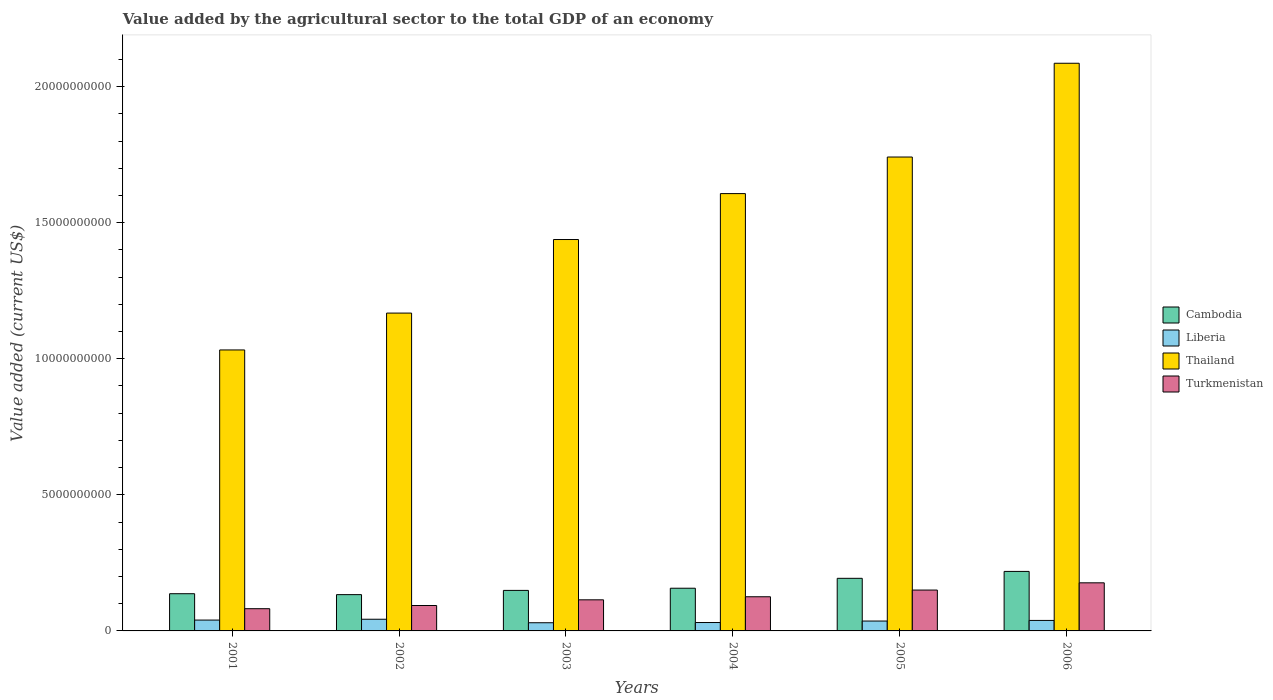How many different coloured bars are there?
Provide a succinct answer. 4. How many groups of bars are there?
Provide a succinct answer. 6. Are the number of bars per tick equal to the number of legend labels?
Your answer should be compact. Yes. How many bars are there on the 6th tick from the right?
Keep it short and to the point. 4. What is the value added by the agricultural sector to the total GDP in Cambodia in 2003?
Give a very brief answer. 1.49e+09. Across all years, what is the maximum value added by the agricultural sector to the total GDP in Liberia?
Your response must be concise. 4.29e+08. Across all years, what is the minimum value added by the agricultural sector to the total GDP in Thailand?
Your response must be concise. 1.03e+1. In which year was the value added by the agricultural sector to the total GDP in Turkmenistan maximum?
Your answer should be very brief. 2006. What is the total value added by the agricultural sector to the total GDP in Liberia in the graph?
Offer a terse response. 2.19e+09. What is the difference between the value added by the agricultural sector to the total GDP in Liberia in 2001 and that in 2003?
Offer a terse response. 9.82e+07. What is the difference between the value added by the agricultural sector to the total GDP in Thailand in 2001 and the value added by the agricultural sector to the total GDP in Turkmenistan in 2004?
Give a very brief answer. 9.07e+09. What is the average value added by the agricultural sector to the total GDP in Thailand per year?
Keep it short and to the point. 1.51e+1. In the year 2003, what is the difference between the value added by the agricultural sector to the total GDP in Liberia and value added by the agricultural sector to the total GDP in Thailand?
Your answer should be very brief. -1.41e+1. In how many years, is the value added by the agricultural sector to the total GDP in Thailand greater than 19000000000 US$?
Your answer should be compact. 1. What is the ratio of the value added by the agricultural sector to the total GDP in Thailand in 2001 to that in 2006?
Ensure brevity in your answer.  0.49. Is the difference between the value added by the agricultural sector to the total GDP in Liberia in 2003 and 2005 greater than the difference between the value added by the agricultural sector to the total GDP in Thailand in 2003 and 2005?
Give a very brief answer. Yes. What is the difference between the highest and the second highest value added by the agricultural sector to the total GDP in Liberia?
Make the answer very short. 3.05e+07. What is the difference between the highest and the lowest value added by the agricultural sector to the total GDP in Cambodia?
Ensure brevity in your answer.  8.53e+08. Is it the case that in every year, the sum of the value added by the agricultural sector to the total GDP in Liberia and value added by the agricultural sector to the total GDP in Cambodia is greater than the sum of value added by the agricultural sector to the total GDP in Turkmenistan and value added by the agricultural sector to the total GDP in Thailand?
Keep it short and to the point. No. What does the 2nd bar from the left in 2002 represents?
Offer a terse response. Liberia. What does the 3rd bar from the right in 2003 represents?
Make the answer very short. Liberia. Are the values on the major ticks of Y-axis written in scientific E-notation?
Offer a terse response. No. Does the graph contain any zero values?
Your answer should be compact. No. Does the graph contain grids?
Offer a terse response. No. How many legend labels are there?
Your answer should be very brief. 4. What is the title of the graph?
Your answer should be compact. Value added by the agricultural sector to the total GDP of an economy. What is the label or title of the Y-axis?
Offer a terse response. Value added (current US$). What is the Value added (current US$) in Cambodia in 2001?
Offer a terse response. 1.37e+09. What is the Value added (current US$) of Liberia in 2001?
Keep it short and to the point. 3.99e+08. What is the Value added (current US$) of Thailand in 2001?
Your answer should be very brief. 1.03e+1. What is the Value added (current US$) of Turkmenistan in 2001?
Your answer should be very brief. 8.16e+08. What is the Value added (current US$) of Cambodia in 2002?
Your response must be concise. 1.33e+09. What is the Value added (current US$) in Liberia in 2002?
Your answer should be very brief. 4.29e+08. What is the Value added (current US$) in Thailand in 2002?
Your answer should be compact. 1.17e+1. What is the Value added (current US$) of Turkmenistan in 2002?
Make the answer very short. 9.34e+08. What is the Value added (current US$) of Cambodia in 2003?
Provide a succinct answer. 1.49e+09. What is the Value added (current US$) in Liberia in 2003?
Offer a terse response. 3.01e+08. What is the Value added (current US$) in Thailand in 2003?
Keep it short and to the point. 1.44e+1. What is the Value added (current US$) of Turkmenistan in 2003?
Keep it short and to the point. 1.14e+09. What is the Value added (current US$) in Cambodia in 2004?
Your response must be concise. 1.57e+09. What is the Value added (current US$) in Liberia in 2004?
Offer a terse response. 3.09e+08. What is the Value added (current US$) in Thailand in 2004?
Your answer should be compact. 1.61e+1. What is the Value added (current US$) in Turkmenistan in 2004?
Your response must be concise. 1.26e+09. What is the Value added (current US$) in Cambodia in 2005?
Your response must be concise. 1.93e+09. What is the Value added (current US$) in Liberia in 2005?
Offer a terse response. 3.63e+08. What is the Value added (current US$) in Thailand in 2005?
Offer a terse response. 1.74e+1. What is the Value added (current US$) of Turkmenistan in 2005?
Provide a succinct answer. 1.50e+09. What is the Value added (current US$) in Cambodia in 2006?
Offer a very short reply. 2.19e+09. What is the Value added (current US$) in Liberia in 2006?
Make the answer very short. 3.85e+08. What is the Value added (current US$) in Thailand in 2006?
Keep it short and to the point. 2.09e+1. What is the Value added (current US$) of Turkmenistan in 2006?
Make the answer very short. 1.77e+09. Across all years, what is the maximum Value added (current US$) of Cambodia?
Give a very brief answer. 2.19e+09. Across all years, what is the maximum Value added (current US$) of Liberia?
Offer a very short reply. 4.29e+08. Across all years, what is the maximum Value added (current US$) of Thailand?
Provide a short and direct response. 2.09e+1. Across all years, what is the maximum Value added (current US$) in Turkmenistan?
Ensure brevity in your answer.  1.77e+09. Across all years, what is the minimum Value added (current US$) in Cambodia?
Your answer should be compact. 1.33e+09. Across all years, what is the minimum Value added (current US$) in Liberia?
Provide a succinct answer. 3.01e+08. Across all years, what is the minimum Value added (current US$) of Thailand?
Keep it short and to the point. 1.03e+1. Across all years, what is the minimum Value added (current US$) in Turkmenistan?
Your answer should be compact. 8.16e+08. What is the total Value added (current US$) of Cambodia in the graph?
Give a very brief answer. 9.88e+09. What is the total Value added (current US$) of Liberia in the graph?
Your answer should be compact. 2.19e+09. What is the total Value added (current US$) of Thailand in the graph?
Provide a short and direct response. 9.07e+1. What is the total Value added (current US$) of Turkmenistan in the graph?
Offer a very short reply. 7.42e+09. What is the difference between the Value added (current US$) of Cambodia in 2001 and that in 2002?
Provide a short and direct response. 3.37e+07. What is the difference between the Value added (current US$) in Liberia in 2001 and that in 2002?
Provide a short and direct response. -3.05e+07. What is the difference between the Value added (current US$) in Thailand in 2001 and that in 2002?
Your answer should be compact. -1.35e+09. What is the difference between the Value added (current US$) of Turkmenistan in 2001 and that in 2002?
Give a very brief answer. -1.18e+08. What is the difference between the Value added (current US$) in Cambodia in 2001 and that in 2003?
Your answer should be very brief. -1.22e+08. What is the difference between the Value added (current US$) of Liberia in 2001 and that in 2003?
Offer a very short reply. 9.82e+07. What is the difference between the Value added (current US$) of Thailand in 2001 and that in 2003?
Keep it short and to the point. -4.06e+09. What is the difference between the Value added (current US$) of Turkmenistan in 2001 and that in 2003?
Give a very brief answer. -3.26e+08. What is the difference between the Value added (current US$) in Cambodia in 2001 and that in 2004?
Keep it short and to the point. -2.01e+08. What is the difference between the Value added (current US$) of Liberia in 2001 and that in 2004?
Make the answer very short. 9.00e+07. What is the difference between the Value added (current US$) in Thailand in 2001 and that in 2004?
Provide a short and direct response. -5.74e+09. What is the difference between the Value added (current US$) in Turkmenistan in 2001 and that in 2004?
Offer a very short reply. -4.39e+08. What is the difference between the Value added (current US$) of Cambodia in 2001 and that in 2005?
Offer a very short reply. -5.65e+08. What is the difference between the Value added (current US$) in Liberia in 2001 and that in 2005?
Provide a short and direct response. 3.56e+07. What is the difference between the Value added (current US$) in Thailand in 2001 and that in 2005?
Offer a very short reply. -7.09e+09. What is the difference between the Value added (current US$) in Turkmenistan in 2001 and that in 2005?
Make the answer very short. -6.85e+08. What is the difference between the Value added (current US$) in Cambodia in 2001 and that in 2006?
Offer a terse response. -8.19e+08. What is the difference between the Value added (current US$) in Liberia in 2001 and that in 2006?
Provide a short and direct response. 1.33e+07. What is the difference between the Value added (current US$) of Thailand in 2001 and that in 2006?
Your answer should be compact. -1.05e+1. What is the difference between the Value added (current US$) in Turkmenistan in 2001 and that in 2006?
Provide a succinct answer. -9.51e+08. What is the difference between the Value added (current US$) of Cambodia in 2002 and that in 2003?
Offer a very short reply. -1.56e+08. What is the difference between the Value added (current US$) in Liberia in 2002 and that in 2003?
Keep it short and to the point. 1.29e+08. What is the difference between the Value added (current US$) of Thailand in 2002 and that in 2003?
Provide a succinct answer. -2.70e+09. What is the difference between the Value added (current US$) of Turkmenistan in 2002 and that in 2003?
Make the answer very short. -2.09e+08. What is the difference between the Value added (current US$) of Cambodia in 2002 and that in 2004?
Keep it short and to the point. -2.35e+08. What is the difference between the Value added (current US$) of Liberia in 2002 and that in 2004?
Provide a short and direct response. 1.20e+08. What is the difference between the Value added (current US$) of Thailand in 2002 and that in 2004?
Offer a very short reply. -4.39e+09. What is the difference between the Value added (current US$) of Turkmenistan in 2002 and that in 2004?
Offer a terse response. -3.21e+08. What is the difference between the Value added (current US$) of Cambodia in 2002 and that in 2005?
Keep it short and to the point. -5.99e+08. What is the difference between the Value added (current US$) in Liberia in 2002 and that in 2005?
Offer a very short reply. 6.60e+07. What is the difference between the Value added (current US$) in Thailand in 2002 and that in 2005?
Offer a very short reply. -5.73e+09. What is the difference between the Value added (current US$) of Turkmenistan in 2002 and that in 2005?
Keep it short and to the point. -5.68e+08. What is the difference between the Value added (current US$) in Cambodia in 2002 and that in 2006?
Your answer should be compact. -8.53e+08. What is the difference between the Value added (current US$) of Liberia in 2002 and that in 2006?
Offer a very short reply. 4.37e+07. What is the difference between the Value added (current US$) of Thailand in 2002 and that in 2006?
Ensure brevity in your answer.  -9.18e+09. What is the difference between the Value added (current US$) in Turkmenistan in 2002 and that in 2006?
Offer a very short reply. -8.33e+08. What is the difference between the Value added (current US$) in Cambodia in 2003 and that in 2004?
Provide a succinct answer. -7.95e+07. What is the difference between the Value added (current US$) of Liberia in 2003 and that in 2004?
Your answer should be compact. -8.26e+06. What is the difference between the Value added (current US$) in Thailand in 2003 and that in 2004?
Make the answer very short. -1.69e+09. What is the difference between the Value added (current US$) of Turkmenistan in 2003 and that in 2004?
Provide a succinct answer. -1.12e+08. What is the difference between the Value added (current US$) of Cambodia in 2003 and that in 2005?
Provide a short and direct response. -4.43e+08. What is the difference between the Value added (current US$) of Liberia in 2003 and that in 2005?
Your response must be concise. -6.27e+07. What is the difference between the Value added (current US$) in Thailand in 2003 and that in 2005?
Offer a terse response. -3.03e+09. What is the difference between the Value added (current US$) in Turkmenistan in 2003 and that in 2005?
Your answer should be very brief. -3.59e+08. What is the difference between the Value added (current US$) in Cambodia in 2003 and that in 2006?
Keep it short and to the point. -6.97e+08. What is the difference between the Value added (current US$) of Liberia in 2003 and that in 2006?
Keep it short and to the point. -8.50e+07. What is the difference between the Value added (current US$) of Thailand in 2003 and that in 2006?
Offer a terse response. -6.48e+09. What is the difference between the Value added (current US$) of Turkmenistan in 2003 and that in 2006?
Provide a succinct answer. -6.25e+08. What is the difference between the Value added (current US$) in Cambodia in 2004 and that in 2005?
Offer a very short reply. -3.64e+08. What is the difference between the Value added (current US$) in Liberia in 2004 and that in 2005?
Your answer should be very brief. -5.44e+07. What is the difference between the Value added (current US$) of Thailand in 2004 and that in 2005?
Offer a very short reply. -1.34e+09. What is the difference between the Value added (current US$) in Turkmenistan in 2004 and that in 2005?
Provide a succinct answer. -2.47e+08. What is the difference between the Value added (current US$) in Cambodia in 2004 and that in 2006?
Keep it short and to the point. -6.18e+08. What is the difference between the Value added (current US$) in Liberia in 2004 and that in 2006?
Keep it short and to the point. -7.67e+07. What is the difference between the Value added (current US$) of Thailand in 2004 and that in 2006?
Offer a very short reply. -4.79e+09. What is the difference between the Value added (current US$) in Turkmenistan in 2004 and that in 2006?
Offer a very short reply. -5.12e+08. What is the difference between the Value added (current US$) of Cambodia in 2005 and that in 2006?
Provide a short and direct response. -2.54e+08. What is the difference between the Value added (current US$) in Liberia in 2005 and that in 2006?
Offer a very short reply. -2.23e+07. What is the difference between the Value added (current US$) in Thailand in 2005 and that in 2006?
Offer a very short reply. -3.45e+09. What is the difference between the Value added (current US$) in Turkmenistan in 2005 and that in 2006?
Make the answer very short. -2.66e+08. What is the difference between the Value added (current US$) of Cambodia in 2001 and the Value added (current US$) of Liberia in 2002?
Your answer should be compact. 9.38e+08. What is the difference between the Value added (current US$) of Cambodia in 2001 and the Value added (current US$) of Thailand in 2002?
Your response must be concise. -1.03e+1. What is the difference between the Value added (current US$) of Cambodia in 2001 and the Value added (current US$) of Turkmenistan in 2002?
Offer a terse response. 4.33e+08. What is the difference between the Value added (current US$) of Liberia in 2001 and the Value added (current US$) of Thailand in 2002?
Give a very brief answer. -1.13e+1. What is the difference between the Value added (current US$) in Liberia in 2001 and the Value added (current US$) in Turkmenistan in 2002?
Offer a very short reply. -5.35e+08. What is the difference between the Value added (current US$) in Thailand in 2001 and the Value added (current US$) in Turkmenistan in 2002?
Give a very brief answer. 9.39e+09. What is the difference between the Value added (current US$) in Cambodia in 2001 and the Value added (current US$) in Liberia in 2003?
Offer a very short reply. 1.07e+09. What is the difference between the Value added (current US$) in Cambodia in 2001 and the Value added (current US$) in Thailand in 2003?
Offer a terse response. -1.30e+1. What is the difference between the Value added (current US$) in Cambodia in 2001 and the Value added (current US$) in Turkmenistan in 2003?
Your answer should be very brief. 2.24e+08. What is the difference between the Value added (current US$) in Liberia in 2001 and the Value added (current US$) in Thailand in 2003?
Make the answer very short. -1.40e+1. What is the difference between the Value added (current US$) of Liberia in 2001 and the Value added (current US$) of Turkmenistan in 2003?
Offer a very short reply. -7.44e+08. What is the difference between the Value added (current US$) in Thailand in 2001 and the Value added (current US$) in Turkmenistan in 2003?
Offer a very short reply. 9.18e+09. What is the difference between the Value added (current US$) in Cambodia in 2001 and the Value added (current US$) in Liberia in 2004?
Provide a succinct answer. 1.06e+09. What is the difference between the Value added (current US$) in Cambodia in 2001 and the Value added (current US$) in Thailand in 2004?
Offer a very short reply. -1.47e+1. What is the difference between the Value added (current US$) in Cambodia in 2001 and the Value added (current US$) in Turkmenistan in 2004?
Offer a terse response. 1.12e+08. What is the difference between the Value added (current US$) in Liberia in 2001 and the Value added (current US$) in Thailand in 2004?
Keep it short and to the point. -1.57e+1. What is the difference between the Value added (current US$) of Liberia in 2001 and the Value added (current US$) of Turkmenistan in 2004?
Your answer should be very brief. -8.56e+08. What is the difference between the Value added (current US$) of Thailand in 2001 and the Value added (current US$) of Turkmenistan in 2004?
Your response must be concise. 9.07e+09. What is the difference between the Value added (current US$) of Cambodia in 2001 and the Value added (current US$) of Liberia in 2005?
Your response must be concise. 1.00e+09. What is the difference between the Value added (current US$) of Cambodia in 2001 and the Value added (current US$) of Thailand in 2005?
Provide a short and direct response. -1.60e+1. What is the difference between the Value added (current US$) in Cambodia in 2001 and the Value added (current US$) in Turkmenistan in 2005?
Provide a short and direct response. -1.34e+08. What is the difference between the Value added (current US$) of Liberia in 2001 and the Value added (current US$) of Thailand in 2005?
Your response must be concise. -1.70e+1. What is the difference between the Value added (current US$) in Liberia in 2001 and the Value added (current US$) in Turkmenistan in 2005?
Your answer should be very brief. -1.10e+09. What is the difference between the Value added (current US$) in Thailand in 2001 and the Value added (current US$) in Turkmenistan in 2005?
Give a very brief answer. 8.82e+09. What is the difference between the Value added (current US$) of Cambodia in 2001 and the Value added (current US$) of Liberia in 2006?
Keep it short and to the point. 9.82e+08. What is the difference between the Value added (current US$) of Cambodia in 2001 and the Value added (current US$) of Thailand in 2006?
Offer a terse response. -1.95e+1. What is the difference between the Value added (current US$) of Cambodia in 2001 and the Value added (current US$) of Turkmenistan in 2006?
Offer a very short reply. -4.00e+08. What is the difference between the Value added (current US$) in Liberia in 2001 and the Value added (current US$) in Thailand in 2006?
Ensure brevity in your answer.  -2.05e+1. What is the difference between the Value added (current US$) in Liberia in 2001 and the Value added (current US$) in Turkmenistan in 2006?
Your answer should be very brief. -1.37e+09. What is the difference between the Value added (current US$) of Thailand in 2001 and the Value added (current US$) of Turkmenistan in 2006?
Make the answer very short. 8.56e+09. What is the difference between the Value added (current US$) in Cambodia in 2002 and the Value added (current US$) in Liberia in 2003?
Keep it short and to the point. 1.03e+09. What is the difference between the Value added (current US$) of Cambodia in 2002 and the Value added (current US$) of Thailand in 2003?
Your answer should be very brief. -1.30e+1. What is the difference between the Value added (current US$) in Cambodia in 2002 and the Value added (current US$) in Turkmenistan in 2003?
Your answer should be compact. 1.91e+08. What is the difference between the Value added (current US$) of Liberia in 2002 and the Value added (current US$) of Thailand in 2003?
Offer a terse response. -1.40e+1. What is the difference between the Value added (current US$) in Liberia in 2002 and the Value added (current US$) in Turkmenistan in 2003?
Keep it short and to the point. -7.14e+08. What is the difference between the Value added (current US$) in Thailand in 2002 and the Value added (current US$) in Turkmenistan in 2003?
Your answer should be compact. 1.05e+1. What is the difference between the Value added (current US$) in Cambodia in 2002 and the Value added (current US$) in Liberia in 2004?
Ensure brevity in your answer.  1.02e+09. What is the difference between the Value added (current US$) in Cambodia in 2002 and the Value added (current US$) in Thailand in 2004?
Offer a very short reply. -1.47e+1. What is the difference between the Value added (current US$) in Cambodia in 2002 and the Value added (current US$) in Turkmenistan in 2004?
Offer a terse response. 7.84e+07. What is the difference between the Value added (current US$) in Liberia in 2002 and the Value added (current US$) in Thailand in 2004?
Your answer should be very brief. -1.56e+1. What is the difference between the Value added (current US$) of Liberia in 2002 and the Value added (current US$) of Turkmenistan in 2004?
Keep it short and to the point. -8.26e+08. What is the difference between the Value added (current US$) in Thailand in 2002 and the Value added (current US$) in Turkmenistan in 2004?
Your response must be concise. 1.04e+1. What is the difference between the Value added (current US$) in Cambodia in 2002 and the Value added (current US$) in Liberia in 2005?
Provide a succinct answer. 9.70e+08. What is the difference between the Value added (current US$) of Cambodia in 2002 and the Value added (current US$) of Thailand in 2005?
Offer a very short reply. -1.61e+1. What is the difference between the Value added (current US$) of Cambodia in 2002 and the Value added (current US$) of Turkmenistan in 2005?
Keep it short and to the point. -1.68e+08. What is the difference between the Value added (current US$) in Liberia in 2002 and the Value added (current US$) in Thailand in 2005?
Ensure brevity in your answer.  -1.70e+1. What is the difference between the Value added (current US$) in Liberia in 2002 and the Value added (current US$) in Turkmenistan in 2005?
Make the answer very short. -1.07e+09. What is the difference between the Value added (current US$) of Thailand in 2002 and the Value added (current US$) of Turkmenistan in 2005?
Your answer should be very brief. 1.02e+1. What is the difference between the Value added (current US$) in Cambodia in 2002 and the Value added (current US$) in Liberia in 2006?
Keep it short and to the point. 9.48e+08. What is the difference between the Value added (current US$) in Cambodia in 2002 and the Value added (current US$) in Thailand in 2006?
Your answer should be very brief. -1.95e+1. What is the difference between the Value added (current US$) in Cambodia in 2002 and the Value added (current US$) in Turkmenistan in 2006?
Keep it short and to the point. -4.34e+08. What is the difference between the Value added (current US$) in Liberia in 2002 and the Value added (current US$) in Thailand in 2006?
Provide a short and direct response. -2.04e+1. What is the difference between the Value added (current US$) of Liberia in 2002 and the Value added (current US$) of Turkmenistan in 2006?
Provide a succinct answer. -1.34e+09. What is the difference between the Value added (current US$) of Thailand in 2002 and the Value added (current US$) of Turkmenistan in 2006?
Offer a terse response. 9.91e+09. What is the difference between the Value added (current US$) of Cambodia in 2003 and the Value added (current US$) of Liberia in 2004?
Ensure brevity in your answer.  1.18e+09. What is the difference between the Value added (current US$) of Cambodia in 2003 and the Value added (current US$) of Thailand in 2004?
Make the answer very short. -1.46e+1. What is the difference between the Value added (current US$) of Cambodia in 2003 and the Value added (current US$) of Turkmenistan in 2004?
Make the answer very short. 2.34e+08. What is the difference between the Value added (current US$) of Liberia in 2003 and the Value added (current US$) of Thailand in 2004?
Keep it short and to the point. -1.58e+1. What is the difference between the Value added (current US$) in Liberia in 2003 and the Value added (current US$) in Turkmenistan in 2004?
Offer a terse response. -9.55e+08. What is the difference between the Value added (current US$) of Thailand in 2003 and the Value added (current US$) of Turkmenistan in 2004?
Keep it short and to the point. 1.31e+1. What is the difference between the Value added (current US$) in Cambodia in 2003 and the Value added (current US$) in Liberia in 2005?
Give a very brief answer. 1.13e+09. What is the difference between the Value added (current US$) in Cambodia in 2003 and the Value added (current US$) in Thailand in 2005?
Keep it short and to the point. -1.59e+1. What is the difference between the Value added (current US$) of Cambodia in 2003 and the Value added (current US$) of Turkmenistan in 2005?
Offer a very short reply. -1.25e+07. What is the difference between the Value added (current US$) in Liberia in 2003 and the Value added (current US$) in Thailand in 2005?
Ensure brevity in your answer.  -1.71e+1. What is the difference between the Value added (current US$) of Liberia in 2003 and the Value added (current US$) of Turkmenistan in 2005?
Provide a short and direct response. -1.20e+09. What is the difference between the Value added (current US$) in Thailand in 2003 and the Value added (current US$) in Turkmenistan in 2005?
Provide a succinct answer. 1.29e+1. What is the difference between the Value added (current US$) in Cambodia in 2003 and the Value added (current US$) in Liberia in 2006?
Give a very brief answer. 1.10e+09. What is the difference between the Value added (current US$) of Cambodia in 2003 and the Value added (current US$) of Thailand in 2006?
Your response must be concise. -1.94e+1. What is the difference between the Value added (current US$) in Cambodia in 2003 and the Value added (current US$) in Turkmenistan in 2006?
Ensure brevity in your answer.  -2.78e+08. What is the difference between the Value added (current US$) in Liberia in 2003 and the Value added (current US$) in Thailand in 2006?
Your answer should be very brief. -2.06e+1. What is the difference between the Value added (current US$) of Liberia in 2003 and the Value added (current US$) of Turkmenistan in 2006?
Offer a very short reply. -1.47e+09. What is the difference between the Value added (current US$) in Thailand in 2003 and the Value added (current US$) in Turkmenistan in 2006?
Your answer should be compact. 1.26e+1. What is the difference between the Value added (current US$) in Cambodia in 2004 and the Value added (current US$) in Liberia in 2005?
Ensure brevity in your answer.  1.21e+09. What is the difference between the Value added (current US$) in Cambodia in 2004 and the Value added (current US$) in Thailand in 2005?
Make the answer very short. -1.58e+1. What is the difference between the Value added (current US$) of Cambodia in 2004 and the Value added (current US$) of Turkmenistan in 2005?
Make the answer very short. 6.70e+07. What is the difference between the Value added (current US$) of Liberia in 2004 and the Value added (current US$) of Thailand in 2005?
Your answer should be very brief. -1.71e+1. What is the difference between the Value added (current US$) of Liberia in 2004 and the Value added (current US$) of Turkmenistan in 2005?
Offer a very short reply. -1.19e+09. What is the difference between the Value added (current US$) of Thailand in 2004 and the Value added (current US$) of Turkmenistan in 2005?
Keep it short and to the point. 1.46e+1. What is the difference between the Value added (current US$) in Cambodia in 2004 and the Value added (current US$) in Liberia in 2006?
Your answer should be compact. 1.18e+09. What is the difference between the Value added (current US$) of Cambodia in 2004 and the Value added (current US$) of Thailand in 2006?
Your answer should be compact. -1.93e+1. What is the difference between the Value added (current US$) in Cambodia in 2004 and the Value added (current US$) in Turkmenistan in 2006?
Give a very brief answer. -1.99e+08. What is the difference between the Value added (current US$) in Liberia in 2004 and the Value added (current US$) in Thailand in 2006?
Make the answer very short. -2.06e+1. What is the difference between the Value added (current US$) of Liberia in 2004 and the Value added (current US$) of Turkmenistan in 2006?
Your answer should be compact. -1.46e+09. What is the difference between the Value added (current US$) of Thailand in 2004 and the Value added (current US$) of Turkmenistan in 2006?
Provide a short and direct response. 1.43e+1. What is the difference between the Value added (current US$) in Cambodia in 2005 and the Value added (current US$) in Liberia in 2006?
Offer a terse response. 1.55e+09. What is the difference between the Value added (current US$) in Cambodia in 2005 and the Value added (current US$) in Thailand in 2006?
Make the answer very short. -1.89e+1. What is the difference between the Value added (current US$) of Cambodia in 2005 and the Value added (current US$) of Turkmenistan in 2006?
Provide a short and direct response. 1.65e+08. What is the difference between the Value added (current US$) in Liberia in 2005 and the Value added (current US$) in Thailand in 2006?
Keep it short and to the point. -2.05e+1. What is the difference between the Value added (current US$) in Liberia in 2005 and the Value added (current US$) in Turkmenistan in 2006?
Give a very brief answer. -1.40e+09. What is the difference between the Value added (current US$) in Thailand in 2005 and the Value added (current US$) in Turkmenistan in 2006?
Your answer should be compact. 1.56e+1. What is the average Value added (current US$) in Cambodia per year?
Provide a succinct answer. 1.65e+09. What is the average Value added (current US$) of Liberia per year?
Provide a short and direct response. 3.64e+08. What is the average Value added (current US$) of Thailand per year?
Provide a succinct answer. 1.51e+1. What is the average Value added (current US$) of Turkmenistan per year?
Keep it short and to the point. 1.24e+09. In the year 2001, what is the difference between the Value added (current US$) in Cambodia and Value added (current US$) in Liberia?
Keep it short and to the point. 9.69e+08. In the year 2001, what is the difference between the Value added (current US$) of Cambodia and Value added (current US$) of Thailand?
Ensure brevity in your answer.  -8.96e+09. In the year 2001, what is the difference between the Value added (current US$) of Cambodia and Value added (current US$) of Turkmenistan?
Give a very brief answer. 5.51e+08. In the year 2001, what is the difference between the Value added (current US$) in Liberia and Value added (current US$) in Thailand?
Ensure brevity in your answer.  -9.93e+09. In the year 2001, what is the difference between the Value added (current US$) of Liberia and Value added (current US$) of Turkmenistan?
Provide a short and direct response. -4.18e+08. In the year 2001, what is the difference between the Value added (current US$) in Thailand and Value added (current US$) in Turkmenistan?
Your response must be concise. 9.51e+09. In the year 2002, what is the difference between the Value added (current US$) of Cambodia and Value added (current US$) of Liberia?
Your response must be concise. 9.04e+08. In the year 2002, what is the difference between the Value added (current US$) of Cambodia and Value added (current US$) of Thailand?
Offer a terse response. -1.03e+1. In the year 2002, what is the difference between the Value added (current US$) of Cambodia and Value added (current US$) of Turkmenistan?
Give a very brief answer. 4.00e+08. In the year 2002, what is the difference between the Value added (current US$) of Liberia and Value added (current US$) of Thailand?
Provide a succinct answer. -1.12e+1. In the year 2002, what is the difference between the Value added (current US$) of Liberia and Value added (current US$) of Turkmenistan?
Your response must be concise. -5.05e+08. In the year 2002, what is the difference between the Value added (current US$) in Thailand and Value added (current US$) in Turkmenistan?
Provide a short and direct response. 1.07e+1. In the year 2003, what is the difference between the Value added (current US$) in Cambodia and Value added (current US$) in Liberia?
Provide a succinct answer. 1.19e+09. In the year 2003, what is the difference between the Value added (current US$) in Cambodia and Value added (current US$) in Thailand?
Your answer should be very brief. -1.29e+1. In the year 2003, what is the difference between the Value added (current US$) of Cambodia and Value added (current US$) of Turkmenistan?
Provide a succinct answer. 3.46e+08. In the year 2003, what is the difference between the Value added (current US$) of Liberia and Value added (current US$) of Thailand?
Make the answer very short. -1.41e+1. In the year 2003, what is the difference between the Value added (current US$) of Liberia and Value added (current US$) of Turkmenistan?
Provide a short and direct response. -8.42e+08. In the year 2003, what is the difference between the Value added (current US$) in Thailand and Value added (current US$) in Turkmenistan?
Provide a succinct answer. 1.32e+1. In the year 2004, what is the difference between the Value added (current US$) in Cambodia and Value added (current US$) in Liberia?
Give a very brief answer. 1.26e+09. In the year 2004, what is the difference between the Value added (current US$) in Cambodia and Value added (current US$) in Thailand?
Your response must be concise. -1.45e+1. In the year 2004, what is the difference between the Value added (current US$) in Cambodia and Value added (current US$) in Turkmenistan?
Keep it short and to the point. 3.14e+08. In the year 2004, what is the difference between the Value added (current US$) of Liberia and Value added (current US$) of Thailand?
Your answer should be compact. -1.58e+1. In the year 2004, what is the difference between the Value added (current US$) in Liberia and Value added (current US$) in Turkmenistan?
Provide a short and direct response. -9.46e+08. In the year 2004, what is the difference between the Value added (current US$) of Thailand and Value added (current US$) of Turkmenistan?
Your answer should be very brief. 1.48e+1. In the year 2005, what is the difference between the Value added (current US$) of Cambodia and Value added (current US$) of Liberia?
Keep it short and to the point. 1.57e+09. In the year 2005, what is the difference between the Value added (current US$) of Cambodia and Value added (current US$) of Thailand?
Your answer should be very brief. -1.55e+1. In the year 2005, what is the difference between the Value added (current US$) in Cambodia and Value added (current US$) in Turkmenistan?
Make the answer very short. 4.31e+08. In the year 2005, what is the difference between the Value added (current US$) of Liberia and Value added (current US$) of Thailand?
Provide a short and direct response. -1.71e+1. In the year 2005, what is the difference between the Value added (current US$) in Liberia and Value added (current US$) in Turkmenistan?
Your answer should be very brief. -1.14e+09. In the year 2005, what is the difference between the Value added (current US$) of Thailand and Value added (current US$) of Turkmenistan?
Provide a short and direct response. 1.59e+1. In the year 2006, what is the difference between the Value added (current US$) in Cambodia and Value added (current US$) in Liberia?
Offer a terse response. 1.80e+09. In the year 2006, what is the difference between the Value added (current US$) of Cambodia and Value added (current US$) of Thailand?
Your answer should be compact. -1.87e+1. In the year 2006, what is the difference between the Value added (current US$) of Cambodia and Value added (current US$) of Turkmenistan?
Provide a short and direct response. 4.19e+08. In the year 2006, what is the difference between the Value added (current US$) of Liberia and Value added (current US$) of Thailand?
Offer a very short reply. -2.05e+1. In the year 2006, what is the difference between the Value added (current US$) in Liberia and Value added (current US$) in Turkmenistan?
Offer a terse response. -1.38e+09. In the year 2006, what is the difference between the Value added (current US$) in Thailand and Value added (current US$) in Turkmenistan?
Offer a terse response. 1.91e+1. What is the ratio of the Value added (current US$) of Cambodia in 2001 to that in 2002?
Give a very brief answer. 1.03. What is the ratio of the Value added (current US$) in Liberia in 2001 to that in 2002?
Provide a succinct answer. 0.93. What is the ratio of the Value added (current US$) of Thailand in 2001 to that in 2002?
Your answer should be compact. 0.88. What is the ratio of the Value added (current US$) of Turkmenistan in 2001 to that in 2002?
Your answer should be compact. 0.87. What is the ratio of the Value added (current US$) in Cambodia in 2001 to that in 2003?
Give a very brief answer. 0.92. What is the ratio of the Value added (current US$) in Liberia in 2001 to that in 2003?
Provide a succinct answer. 1.33. What is the ratio of the Value added (current US$) of Thailand in 2001 to that in 2003?
Keep it short and to the point. 0.72. What is the ratio of the Value added (current US$) of Turkmenistan in 2001 to that in 2003?
Give a very brief answer. 0.71. What is the ratio of the Value added (current US$) of Cambodia in 2001 to that in 2004?
Provide a succinct answer. 0.87. What is the ratio of the Value added (current US$) in Liberia in 2001 to that in 2004?
Your answer should be very brief. 1.29. What is the ratio of the Value added (current US$) in Thailand in 2001 to that in 2004?
Make the answer very short. 0.64. What is the ratio of the Value added (current US$) of Turkmenistan in 2001 to that in 2004?
Your response must be concise. 0.65. What is the ratio of the Value added (current US$) in Cambodia in 2001 to that in 2005?
Your answer should be compact. 0.71. What is the ratio of the Value added (current US$) of Liberia in 2001 to that in 2005?
Provide a succinct answer. 1.1. What is the ratio of the Value added (current US$) in Thailand in 2001 to that in 2005?
Ensure brevity in your answer.  0.59. What is the ratio of the Value added (current US$) of Turkmenistan in 2001 to that in 2005?
Your response must be concise. 0.54. What is the ratio of the Value added (current US$) of Cambodia in 2001 to that in 2006?
Give a very brief answer. 0.63. What is the ratio of the Value added (current US$) in Liberia in 2001 to that in 2006?
Offer a terse response. 1.03. What is the ratio of the Value added (current US$) in Thailand in 2001 to that in 2006?
Provide a succinct answer. 0.49. What is the ratio of the Value added (current US$) in Turkmenistan in 2001 to that in 2006?
Provide a short and direct response. 0.46. What is the ratio of the Value added (current US$) of Cambodia in 2002 to that in 2003?
Offer a very short reply. 0.9. What is the ratio of the Value added (current US$) in Liberia in 2002 to that in 2003?
Your answer should be compact. 1.43. What is the ratio of the Value added (current US$) in Thailand in 2002 to that in 2003?
Offer a very short reply. 0.81. What is the ratio of the Value added (current US$) in Turkmenistan in 2002 to that in 2003?
Provide a succinct answer. 0.82. What is the ratio of the Value added (current US$) of Cambodia in 2002 to that in 2004?
Provide a succinct answer. 0.85. What is the ratio of the Value added (current US$) of Liberia in 2002 to that in 2004?
Your answer should be compact. 1.39. What is the ratio of the Value added (current US$) in Thailand in 2002 to that in 2004?
Give a very brief answer. 0.73. What is the ratio of the Value added (current US$) of Turkmenistan in 2002 to that in 2004?
Your answer should be compact. 0.74. What is the ratio of the Value added (current US$) of Cambodia in 2002 to that in 2005?
Make the answer very short. 0.69. What is the ratio of the Value added (current US$) in Liberia in 2002 to that in 2005?
Ensure brevity in your answer.  1.18. What is the ratio of the Value added (current US$) in Thailand in 2002 to that in 2005?
Offer a very short reply. 0.67. What is the ratio of the Value added (current US$) in Turkmenistan in 2002 to that in 2005?
Offer a very short reply. 0.62. What is the ratio of the Value added (current US$) of Cambodia in 2002 to that in 2006?
Make the answer very short. 0.61. What is the ratio of the Value added (current US$) of Liberia in 2002 to that in 2006?
Offer a terse response. 1.11. What is the ratio of the Value added (current US$) of Thailand in 2002 to that in 2006?
Offer a terse response. 0.56. What is the ratio of the Value added (current US$) of Turkmenistan in 2002 to that in 2006?
Provide a short and direct response. 0.53. What is the ratio of the Value added (current US$) in Cambodia in 2003 to that in 2004?
Your answer should be very brief. 0.95. What is the ratio of the Value added (current US$) of Liberia in 2003 to that in 2004?
Offer a very short reply. 0.97. What is the ratio of the Value added (current US$) of Thailand in 2003 to that in 2004?
Provide a succinct answer. 0.9. What is the ratio of the Value added (current US$) of Turkmenistan in 2003 to that in 2004?
Offer a terse response. 0.91. What is the ratio of the Value added (current US$) of Cambodia in 2003 to that in 2005?
Your answer should be compact. 0.77. What is the ratio of the Value added (current US$) of Liberia in 2003 to that in 2005?
Offer a terse response. 0.83. What is the ratio of the Value added (current US$) of Thailand in 2003 to that in 2005?
Provide a short and direct response. 0.83. What is the ratio of the Value added (current US$) of Turkmenistan in 2003 to that in 2005?
Your answer should be compact. 0.76. What is the ratio of the Value added (current US$) in Cambodia in 2003 to that in 2006?
Provide a short and direct response. 0.68. What is the ratio of the Value added (current US$) of Liberia in 2003 to that in 2006?
Offer a terse response. 0.78. What is the ratio of the Value added (current US$) of Thailand in 2003 to that in 2006?
Your answer should be very brief. 0.69. What is the ratio of the Value added (current US$) of Turkmenistan in 2003 to that in 2006?
Ensure brevity in your answer.  0.65. What is the ratio of the Value added (current US$) in Cambodia in 2004 to that in 2005?
Ensure brevity in your answer.  0.81. What is the ratio of the Value added (current US$) in Liberia in 2004 to that in 2005?
Your response must be concise. 0.85. What is the ratio of the Value added (current US$) of Thailand in 2004 to that in 2005?
Ensure brevity in your answer.  0.92. What is the ratio of the Value added (current US$) in Turkmenistan in 2004 to that in 2005?
Provide a succinct answer. 0.84. What is the ratio of the Value added (current US$) of Cambodia in 2004 to that in 2006?
Give a very brief answer. 0.72. What is the ratio of the Value added (current US$) of Liberia in 2004 to that in 2006?
Give a very brief answer. 0.8. What is the ratio of the Value added (current US$) in Thailand in 2004 to that in 2006?
Provide a succinct answer. 0.77. What is the ratio of the Value added (current US$) in Turkmenistan in 2004 to that in 2006?
Make the answer very short. 0.71. What is the ratio of the Value added (current US$) of Cambodia in 2005 to that in 2006?
Offer a very short reply. 0.88. What is the ratio of the Value added (current US$) of Liberia in 2005 to that in 2006?
Keep it short and to the point. 0.94. What is the ratio of the Value added (current US$) in Thailand in 2005 to that in 2006?
Provide a short and direct response. 0.83. What is the ratio of the Value added (current US$) in Turkmenistan in 2005 to that in 2006?
Keep it short and to the point. 0.85. What is the difference between the highest and the second highest Value added (current US$) of Cambodia?
Your answer should be compact. 2.54e+08. What is the difference between the highest and the second highest Value added (current US$) of Liberia?
Your answer should be compact. 3.05e+07. What is the difference between the highest and the second highest Value added (current US$) in Thailand?
Provide a succinct answer. 3.45e+09. What is the difference between the highest and the second highest Value added (current US$) in Turkmenistan?
Ensure brevity in your answer.  2.66e+08. What is the difference between the highest and the lowest Value added (current US$) of Cambodia?
Make the answer very short. 8.53e+08. What is the difference between the highest and the lowest Value added (current US$) of Liberia?
Your answer should be compact. 1.29e+08. What is the difference between the highest and the lowest Value added (current US$) of Thailand?
Provide a succinct answer. 1.05e+1. What is the difference between the highest and the lowest Value added (current US$) in Turkmenistan?
Ensure brevity in your answer.  9.51e+08. 